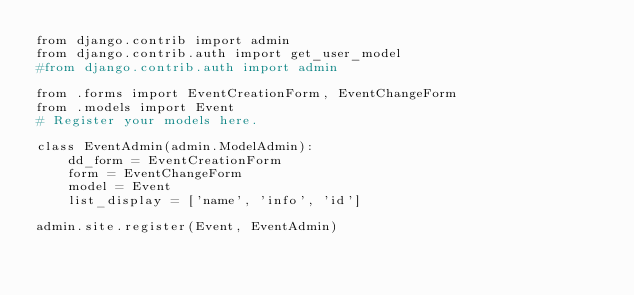Convert code to text. <code><loc_0><loc_0><loc_500><loc_500><_Python_>from django.contrib import admin
from django.contrib.auth import get_user_model
#from django.contrib.auth import admin

from .forms import EventCreationForm, EventChangeForm
from .models import Event
# Register your models here.

class EventAdmin(admin.ModelAdmin):
    dd_form = EventCreationForm
    form = EventChangeForm
    model = Event
    list_display = ['name', 'info', 'id']

admin.site.register(Event, EventAdmin)</code> 